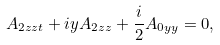<formula> <loc_0><loc_0><loc_500><loc_500>A _ { 2 z z t } + i y A _ { 2 z z } + \frac { i } { 2 } A _ { 0 y y } = 0 ,</formula> 